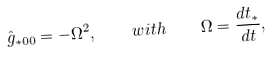Convert formula to latex. <formula><loc_0><loc_0><loc_500><loc_500>\hat { g } _ { * 0 0 } = - \Omega ^ { 2 } , \quad w i t h \quad \Omega = \frac { d t _ { * } } { d t } ,</formula> 